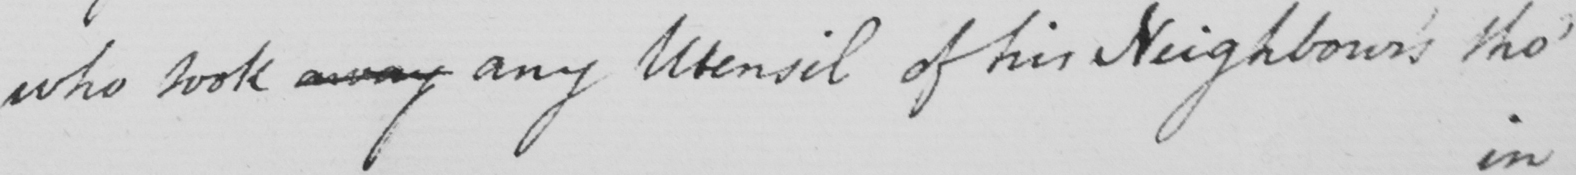What is written in this line of handwriting? who took away any Utensil of his Neighbour ' s tho ' 